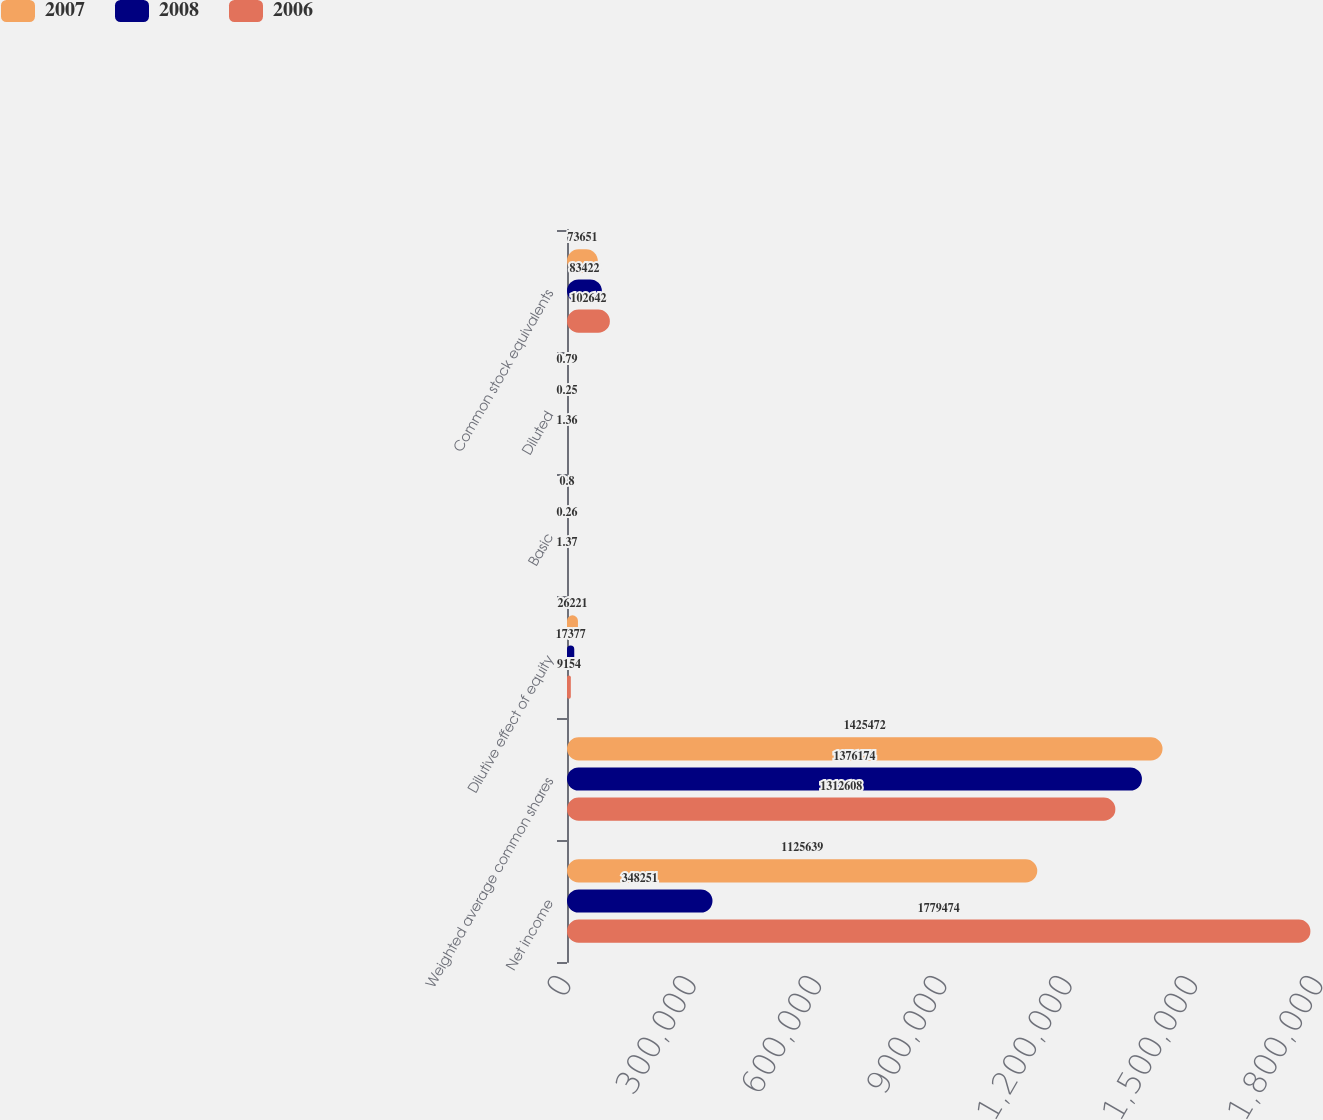<chart> <loc_0><loc_0><loc_500><loc_500><stacked_bar_chart><ecel><fcel>Net income<fcel>Weighted average common shares<fcel>Dilutive effect of equity<fcel>Basic<fcel>Diluted<fcel>Common stock equivalents<nl><fcel>2007<fcel>1.12564e+06<fcel>1.42547e+06<fcel>26221<fcel>0.8<fcel>0.79<fcel>73651<nl><fcel>2008<fcel>348251<fcel>1.37617e+06<fcel>17377<fcel>0.26<fcel>0.25<fcel>83422<nl><fcel>2006<fcel>1.77947e+06<fcel>1.31261e+06<fcel>9154<fcel>1.37<fcel>1.36<fcel>102642<nl></chart> 